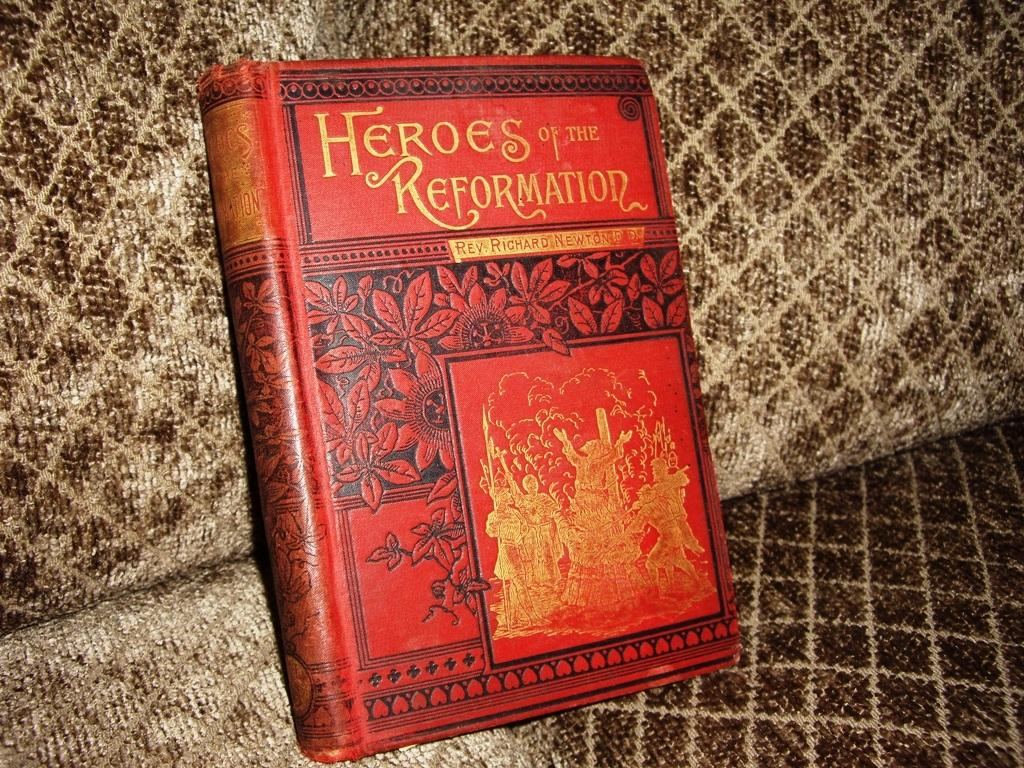What object is placed on the sofa in the image? There is a book on the sofa. Can you describe the setting of the image? The image is likely taken in a house. What type of pollution is visible in the image? There is no pollution visible in the image; it only features a book on a sofa. What nation is represented by the book in the image? The image does not provide any information about the nation represented by the book. 